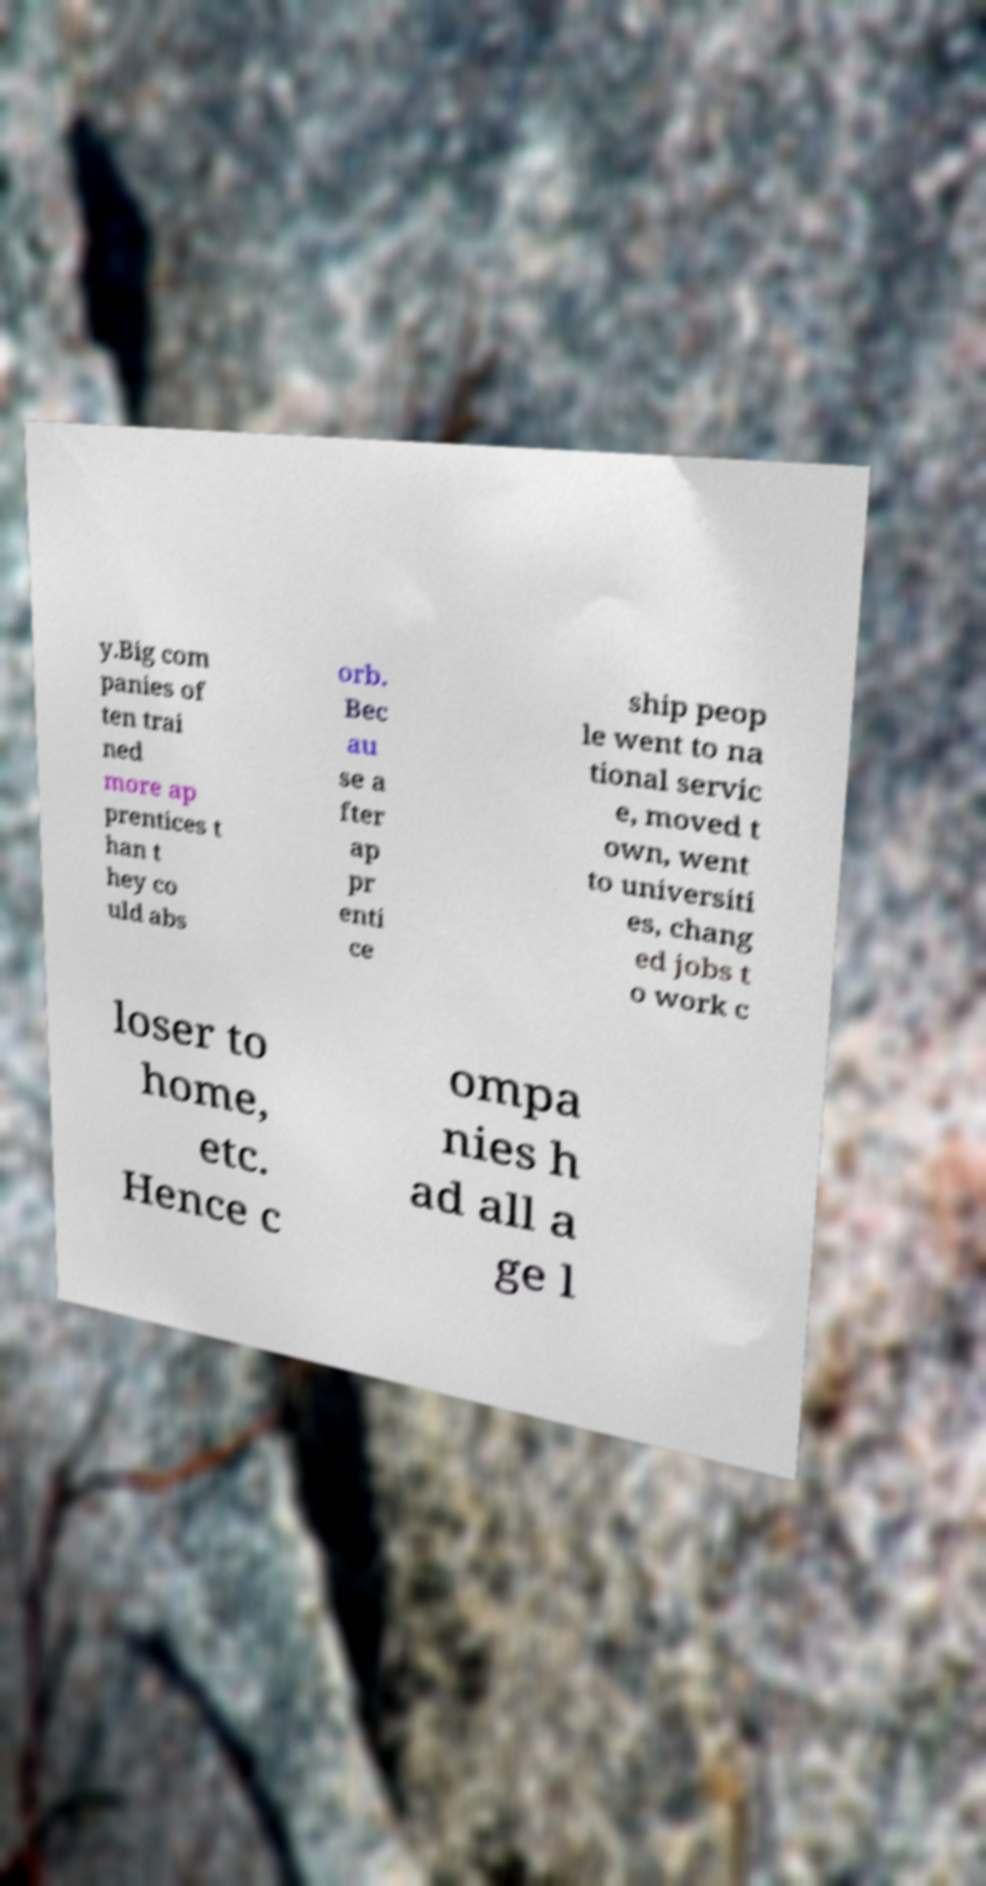I need the written content from this picture converted into text. Can you do that? y.Big com panies of ten trai ned more ap prentices t han t hey co uld abs orb. Bec au se a fter ap pr enti ce ship peop le went to na tional servic e, moved t own, went to universiti es, chang ed jobs t o work c loser to home, etc. Hence c ompa nies h ad all a ge l 